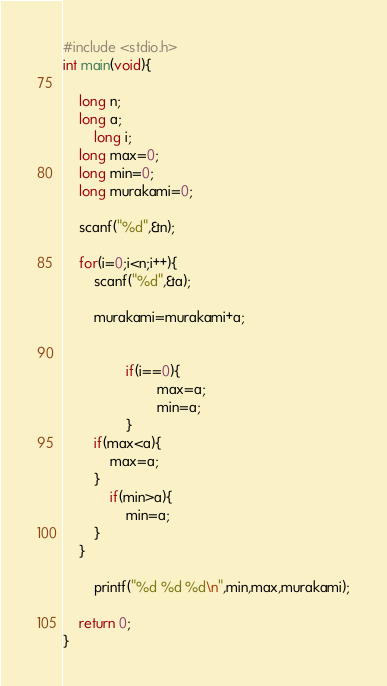Convert code to text. <code><loc_0><loc_0><loc_500><loc_500><_C_>#include <stdio.h>
int main(void){
	
	long n;
	long a;
        long i;
	long max=0;
	long min=0;
	long murakami=0;
	
	scanf("%d",&n);
	
	for(i=0;i<n;i++){
		scanf("%d",&a);
		
		murakami=murakami+a;
		

                if(i==0){
                        max=a;
                        min=a;
                }
		if(max<a){
			max=a;
		}
	        if(min>a){
		        min=a;
		}
	}
		
		printf("%d %d %d\n",min,max,murakami);
	
	return 0;
}</code> 